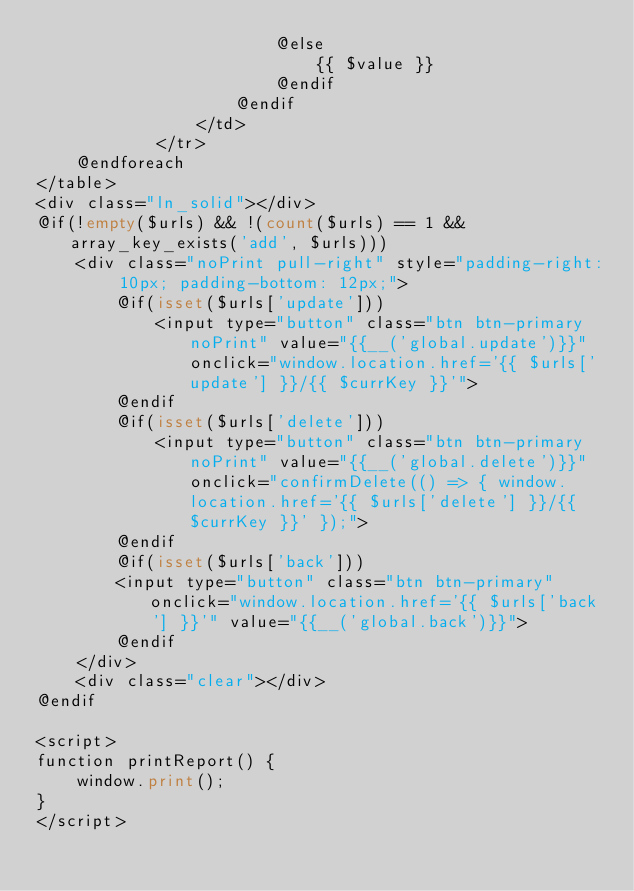<code> <loc_0><loc_0><loc_500><loc_500><_PHP_>                        @else
                            {{ $value }}
                        @endif
                    @endif
                </td>
            </tr>
    @endforeach
</table>
<div class="ln_solid"></div>
@if(!empty($urls) && !(count($urls) == 1 && array_key_exists('add', $urls)))
    <div class="noPrint pull-right" style="padding-right: 10px; padding-bottom: 12px;">
        @if(isset($urls['update']))
            <input type="button" class="btn btn-primary noPrint" value="{{__('global.update')}}" onclick="window.location.href='{{ $urls['update'] }}/{{ $currKey }}'">
        @endif
        @if(isset($urls['delete']))
            <input type="button" class="btn btn-primary noPrint" value="{{__('global.delete')}}" onclick="confirmDelete(() => { window.location.href='{{ $urls['delete'] }}/{{ $currKey }}' });">
        @endif
        @if(isset($urls['back']))
        <input type="button" class="btn btn-primary" onclick="window.location.href='{{ $urls['back'] }}'" value="{{__('global.back')}}">
        @endif
    </div>
    <div class="clear"></div>
@endif

<script>
function printReport() {
    window.print();
}
</script></code> 